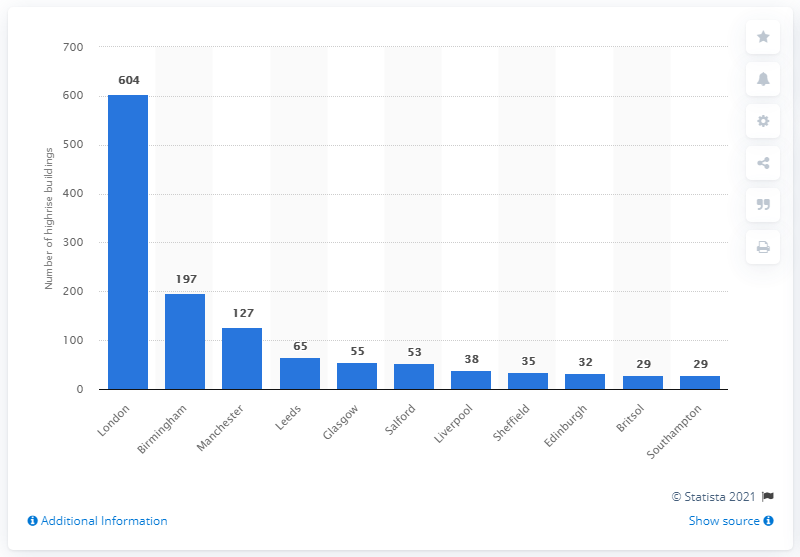Specify some key components in this picture. The majority of high-rise buildings in the given statistic are located in London. 